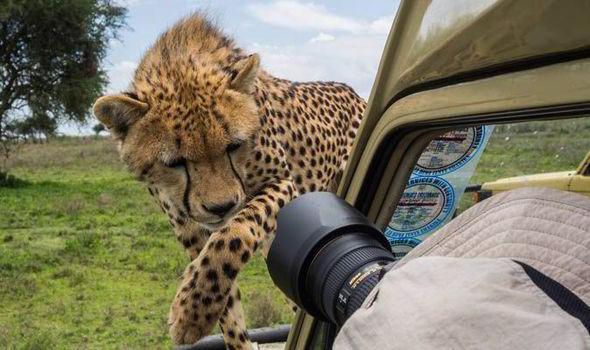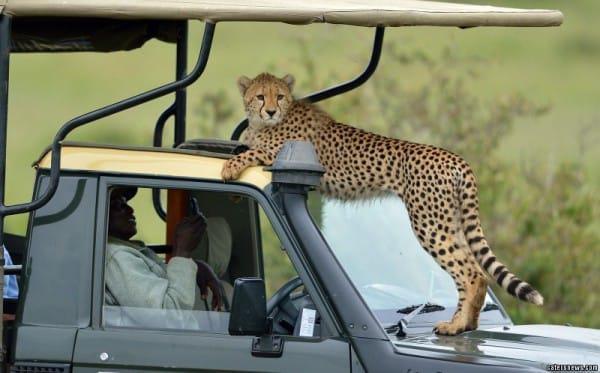The first image is the image on the left, the second image is the image on the right. Assess this claim about the two images: "In one image, a cheetah is on a seat in the vehicle.". Correct or not? Answer yes or no. No. The first image is the image on the left, the second image is the image on the right. For the images displayed, is the sentence "The left image shows a cheetah inside a vehicle perched on the back seat, and the right image shows a cheetah with its body facing the camera, draping its front paws over part of the vehicle's frame." factually correct? Answer yes or no. No. 